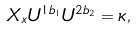Convert formula to latex. <formula><loc_0><loc_0><loc_500><loc_500>X _ { x } U ^ { 1 b _ { 1 } } U ^ { 2 b _ { 2 } } = \kappa ,</formula> 